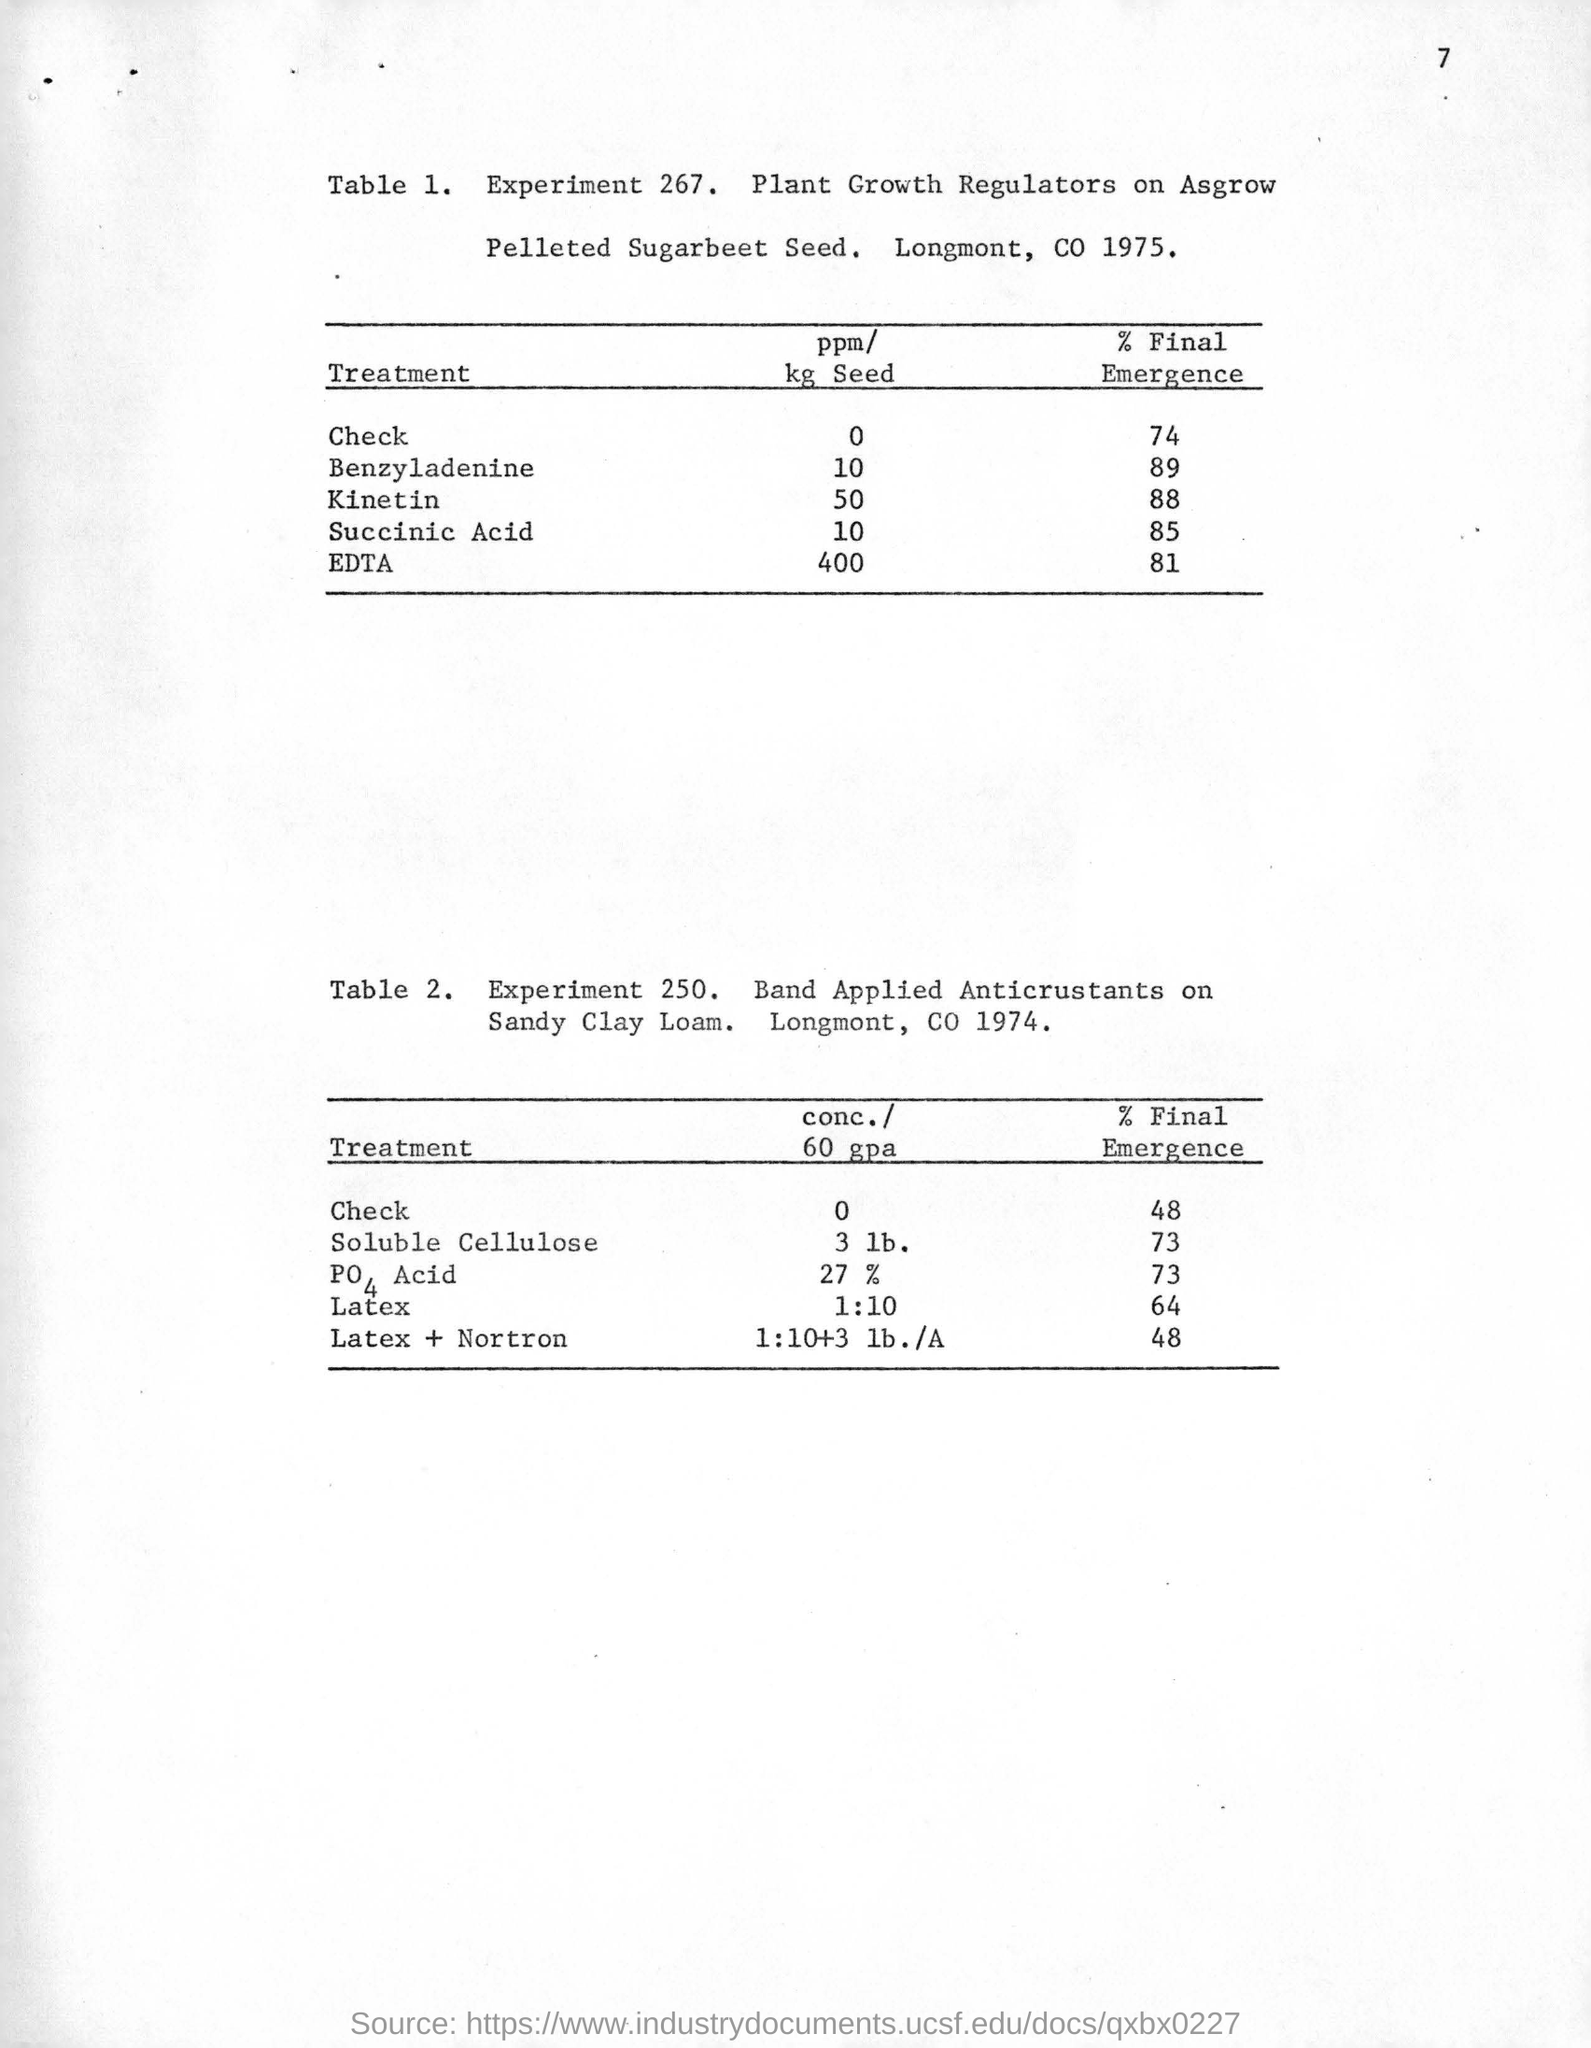Which treatment is needed for the 400 ppm/kg seed ?
Provide a succinct answer. EDTA. What is the final emergence (%) value for EDTA treatment where ppm/kg seed is 400?
Your answer should be compact. 81. Which experiment ( experiment number) is shown in Table 1.?
Offer a very short reply. 267. 